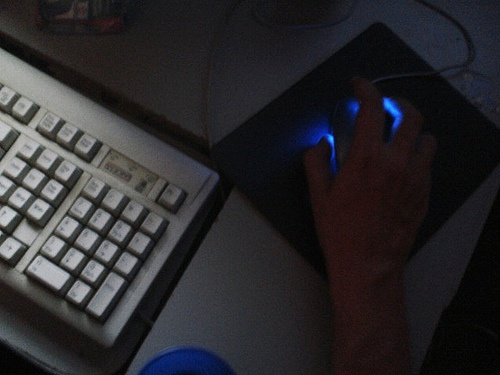Describe the objects in this image and their specific colors. I can see keyboard in black, gray, and darkgray tones, people in black, navy, darkblue, and blue tones, and mouse in black, navy, darkblue, and blue tones in this image. 